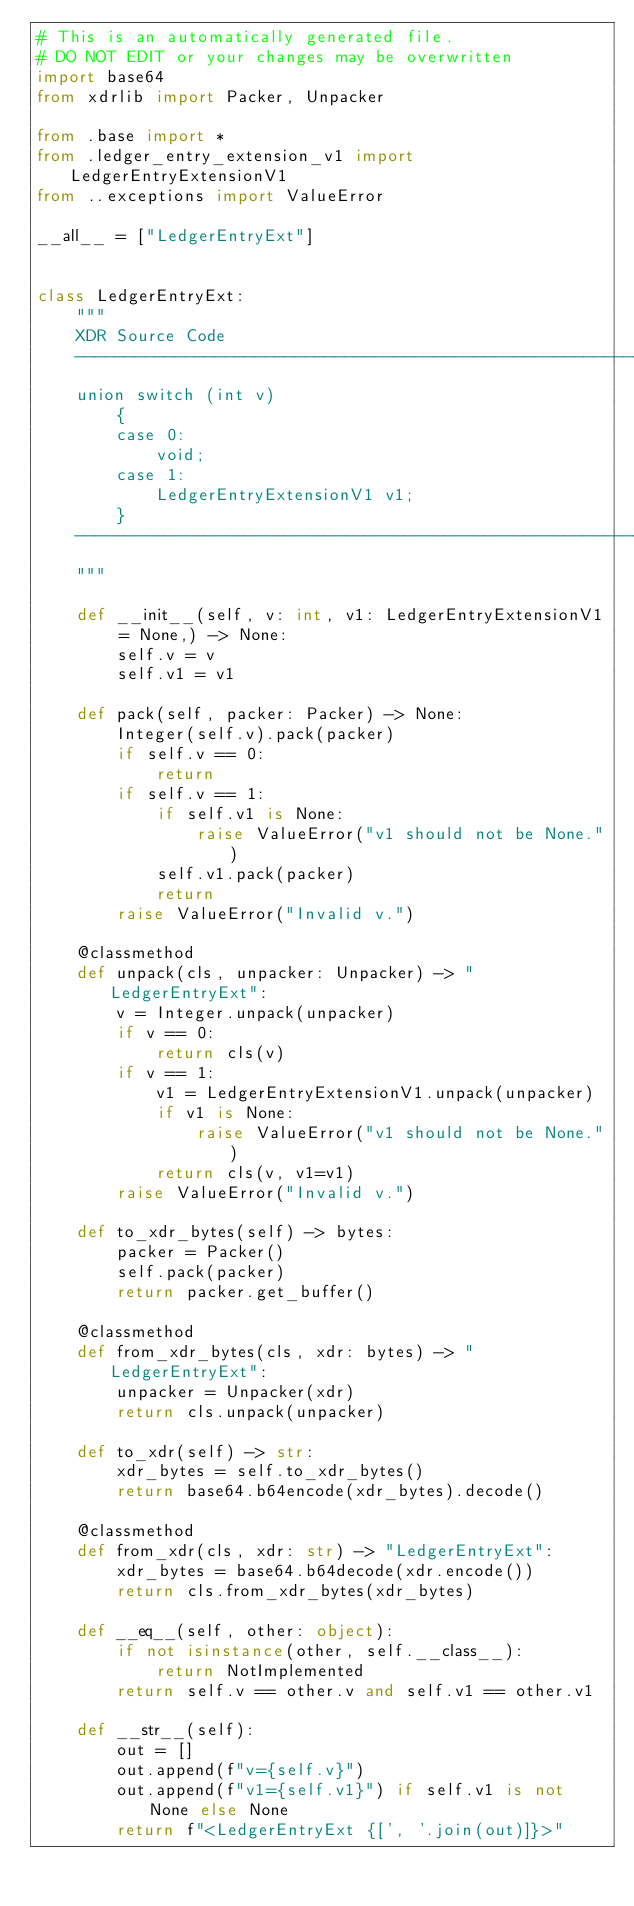Convert code to text. <code><loc_0><loc_0><loc_500><loc_500><_Python_># This is an automatically generated file.
# DO NOT EDIT or your changes may be overwritten
import base64
from xdrlib import Packer, Unpacker

from .base import *
from .ledger_entry_extension_v1 import LedgerEntryExtensionV1
from ..exceptions import ValueError

__all__ = ["LedgerEntryExt"]


class LedgerEntryExt:
    """
    XDR Source Code
    ----------------------------------------------------------------
    union switch (int v)
        {
        case 0:
            void;
        case 1:
            LedgerEntryExtensionV1 v1;
        }
    ----------------------------------------------------------------
    """

    def __init__(self, v: int, v1: LedgerEntryExtensionV1 = None,) -> None:
        self.v = v
        self.v1 = v1

    def pack(self, packer: Packer) -> None:
        Integer(self.v).pack(packer)
        if self.v == 0:
            return
        if self.v == 1:
            if self.v1 is None:
                raise ValueError("v1 should not be None.")
            self.v1.pack(packer)
            return
        raise ValueError("Invalid v.")

    @classmethod
    def unpack(cls, unpacker: Unpacker) -> "LedgerEntryExt":
        v = Integer.unpack(unpacker)
        if v == 0:
            return cls(v)
        if v == 1:
            v1 = LedgerEntryExtensionV1.unpack(unpacker)
            if v1 is None:
                raise ValueError("v1 should not be None.")
            return cls(v, v1=v1)
        raise ValueError("Invalid v.")

    def to_xdr_bytes(self) -> bytes:
        packer = Packer()
        self.pack(packer)
        return packer.get_buffer()

    @classmethod
    def from_xdr_bytes(cls, xdr: bytes) -> "LedgerEntryExt":
        unpacker = Unpacker(xdr)
        return cls.unpack(unpacker)

    def to_xdr(self) -> str:
        xdr_bytes = self.to_xdr_bytes()
        return base64.b64encode(xdr_bytes).decode()

    @classmethod
    def from_xdr(cls, xdr: str) -> "LedgerEntryExt":
        xdr_bytes = base64.b64decode(xdr.encode())
        return cls.from_xdr_bytes(xdr_bytes)

    def __eq__(self, other: object):
        if not isinstance(other, self.__class__):
            return NotImplemented
        return self.v == other.v and self.v1 == other.v1

    def __str__(self):
        out = []
        out.append(f"v={self.v}")
        out.append(f"v1={self.v1}") if self.v1 is not None else None
        return f"<LedgerEntryExt {[', '.join(out)]}>"
</code> 